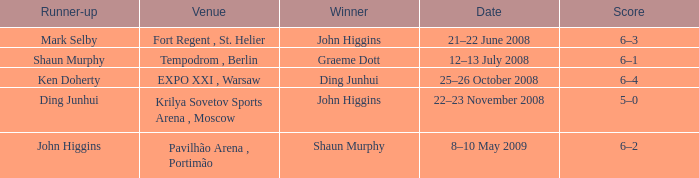Who was the winner in the match that had John Higgins as runner-up? Shaun Murphy. 